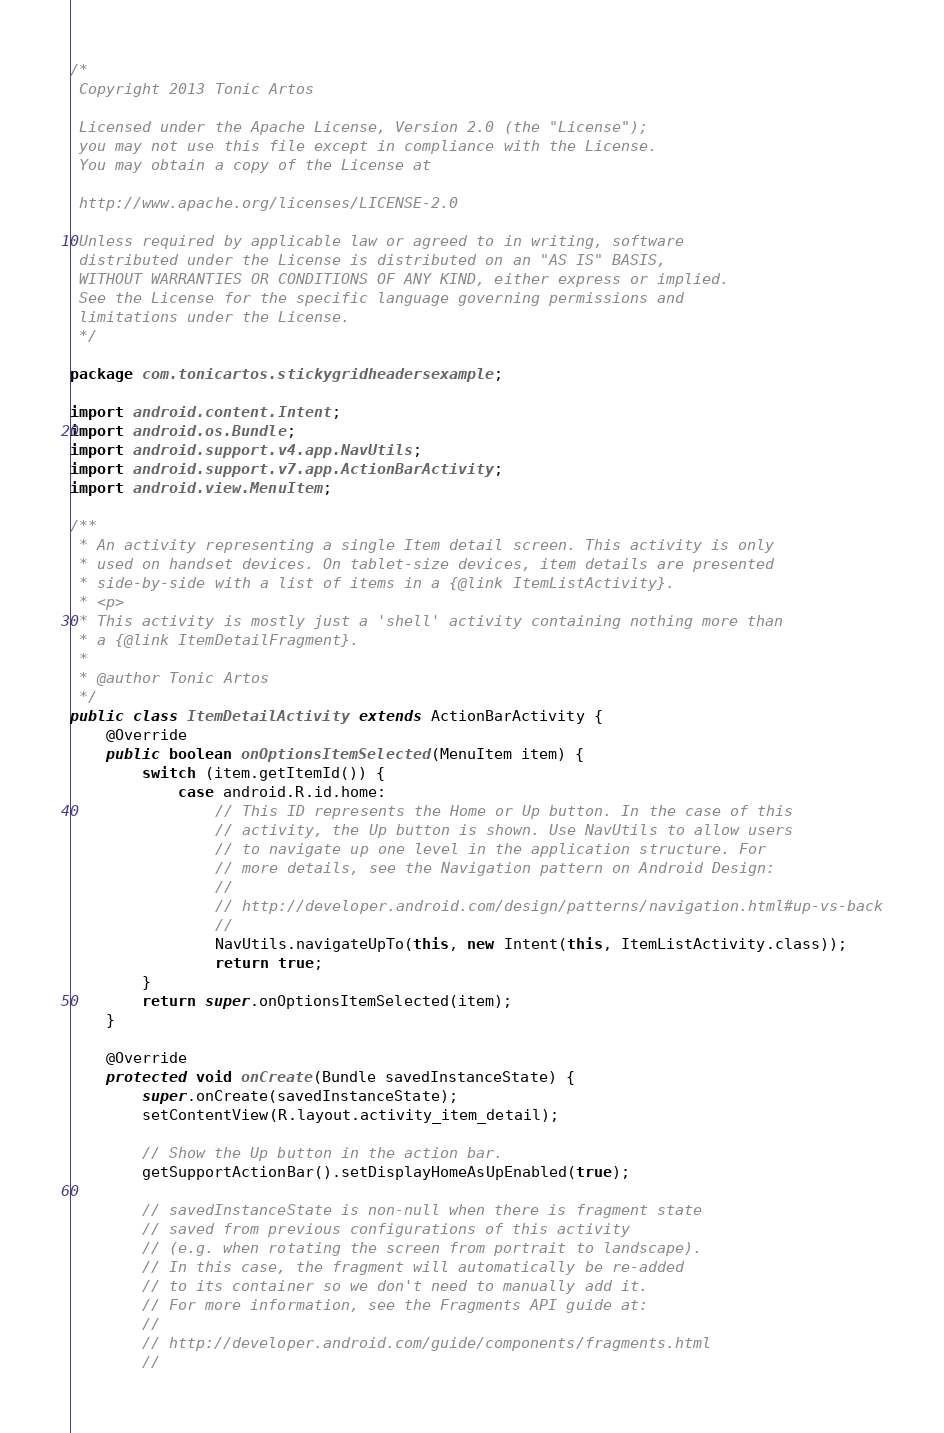Convert code to text. <code><loc_0><loc_0><loc_500><loc_500><_Java_>/*
 Copyright 2013 Tonic Artos

 Licensed under the Apache License, Version 2.0 (the "License");
 you may not use this file except in compliance with the License.
 You may obtain a copy of the License at

 http://www.apache.org/licenses/LICENSE-2.0

 Unless required by applicable law or agreed to in writing, software
 distributed under the License is distributed on an "AS IS" BASIS,
 WITHOUT WARRANTIES OR CONDITIONS OF ANY KIND, either express or implied.
 See the License for the specific language governing permissions and
 limitations under the License.
 */

package com.tonicartos.stickygridheadersexample;

import android.content.Intent;
import android.os.Bundle;
import android.support.v4.app.NavUtils;
import android.support.v7.app.ActionBarActivity;
import android.view.MenuItem;

/**
 * An activity representing a single Item detail screen. This activity is only
 * used on handset devices. On tablet-size devices, item details are presented
 * side-by-side with a list of items in a {@link ItemListActivity}.
 * <p>
 * This activity is mostly just a 'shell' activity containing nothing more than
 * a {@link ItemDetailFragment}.
 * 
 * @author Tonic Artos
 */
public class ItemDetailActivity extends ActionBarActivity {
    @Override
    public boolean onOptionsItemSelected(MenuItem item) {
        switch (item.getItemId()) {
            case android.R.id.home:
                // This ID represents the Home or Up button. In the case of this
                // activity, the Up button is shown. Use NavUtils to allow users
                // to navigate up one level in the application structure. For
                // more details, see the Navigation pattern on Android Design:
                //
                // http://developer.android.com/design/patterns/navigation.html#up-vs-back
                //
                NavUtils.navigateUpTo(this, new Intent(this, ItemListActivity.class));
                return true;
        }
        return super.onOptionsItemSelected(item);
    }

    @Override
    protected void onCreate(Bundle savedInstanceState) {
        super.onCreate(savedInstanceState);
        setContentView(R.layout.activity_item_detail);

        // Show the Up button in the action bar.
        getSupportActionBar().setDisplayHomeAsUpEnabled(true);

        // savedInstanceState is non-null when there is fragment state
        // saved from previous configurations of this activity
        // (e.g. when rotating the screen from portrait to landscape).
        // In this case, the fragment will automatically be re-added
        // to its container so we don't need to manually add it.
        // For more information, see the Fragments API guide at:
        //
        // http://developer.android.com/guide/components/fragments.html
        //</code> 